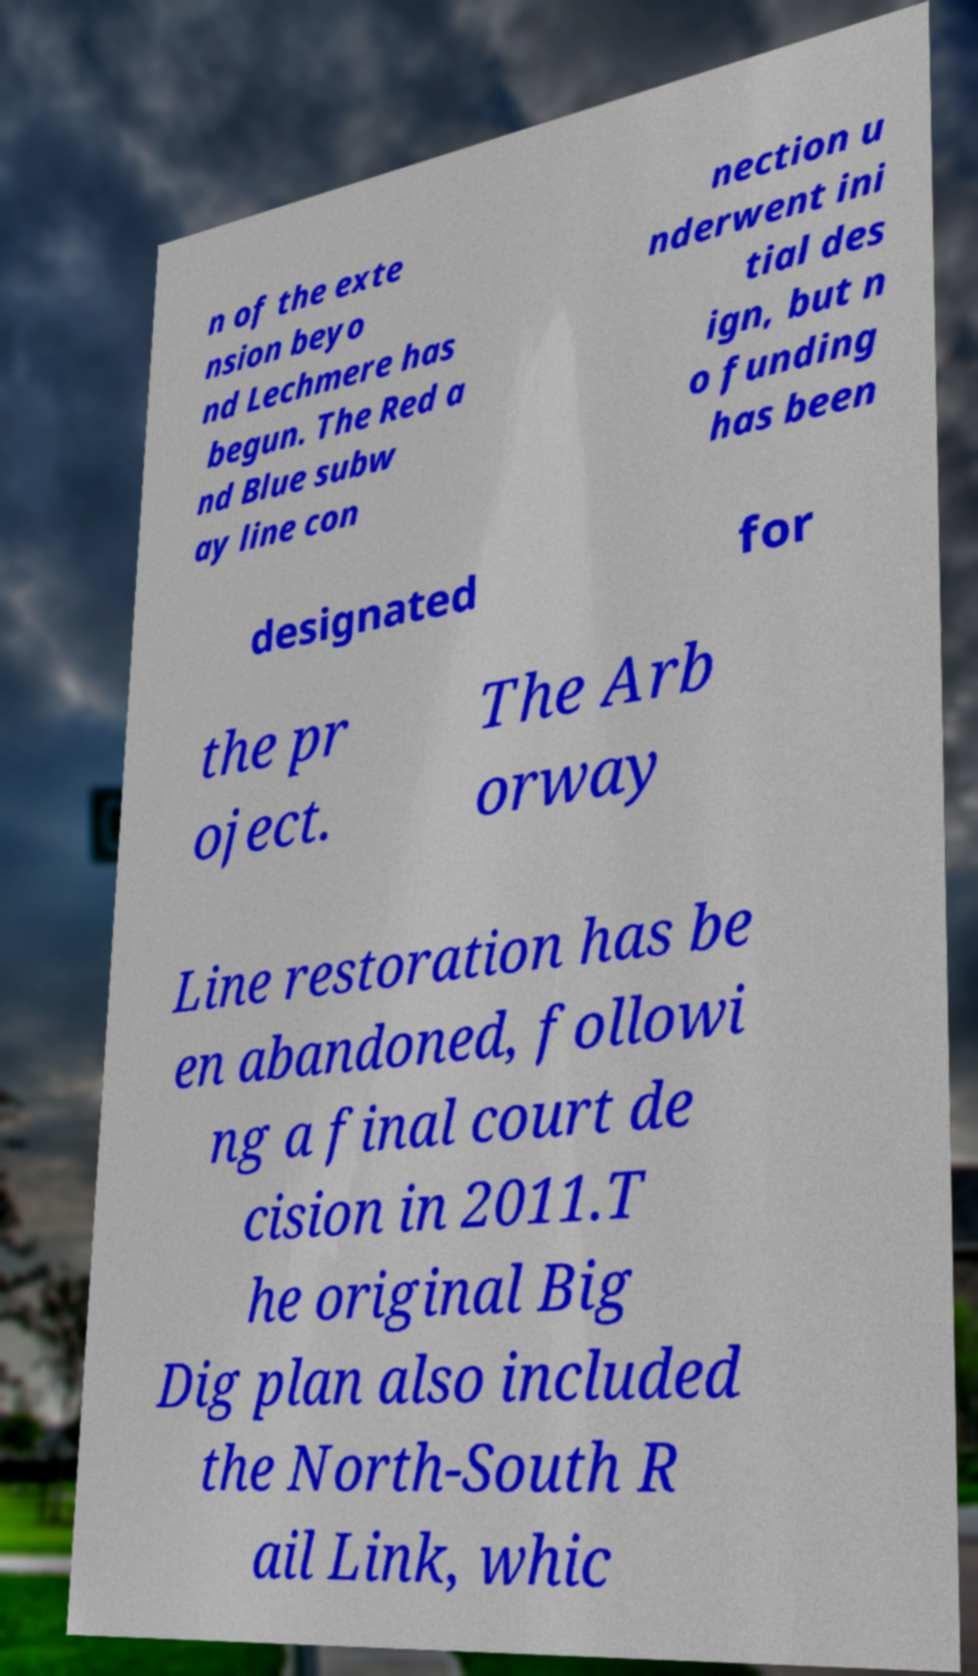What messages or text are displayed in this image? I need them in a readable, typed format. n of the exte nsion beyo nd Lechmere has begun. The Red a nd Blue subw ay line con nection u nderwent ini tial des ign, but n o funding has been designated for the pr oject. The Arb orway Line restoration has be en abandoned, followi ng a final court de cision in 2011.T he original Big Dig plan also included the North-South R ail Link, whic 